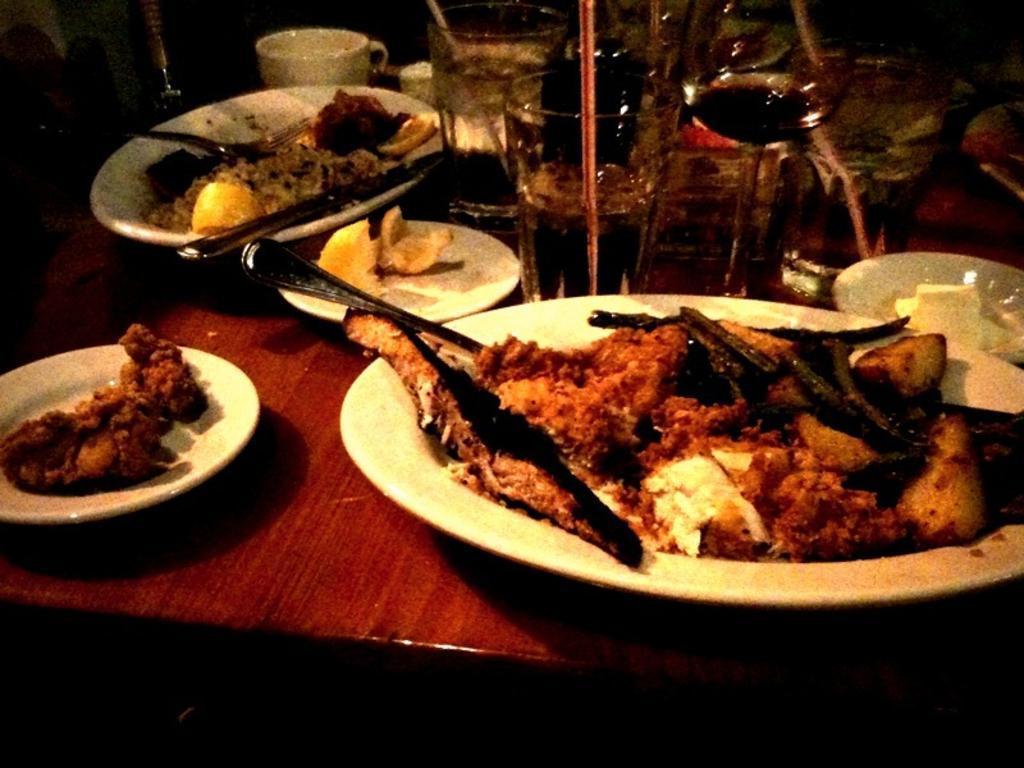How would you summarize this image in a sentence or two? In this picture we can see a table, there are some plates, glasses of drinks and a mug present on the table, we can see some food in these plates, we can also see spoons in these plates. 